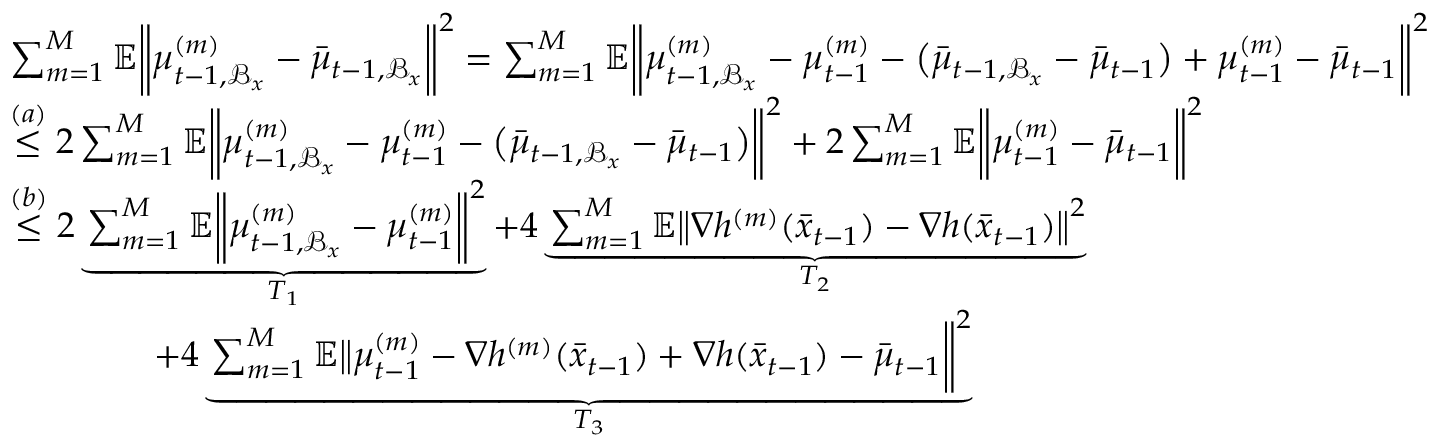Convert formula to latex. <formula><loc_0><loc_0><loc_500><loc_500>\begin{array} { r l } & { \sum _ { m = 1 } ^ { M } \mathbb { E } \left \| \mu _ { t - 1 , \mathcal { B } _ { x } } ^ { ( m ) } - \bar { \mu } _ { t - 1 , \mathcal { B } _ { x } } \right \| ^ { 2 } = \sum _ { m = 1 } ^ { M } \mathbb { E } \left \| \mu _ { t - 1 , \mathcal { B } _ { x } } ^ { ( m ) } - \mu _ { t - 1 } ^ { ( m ) } - \left ( \bar { \mu } _ { t - 1 , \mathcal { B } _ { x } } - \bar { \mu } _ { t - 1 } \right ) + \mu _ { t - 1 } ^ { ( m ) } - \bar { \mu } _ { t - 1 } \right \| ^ { 2 } } \\ & { \overset { ( a ) } { \leq } 2 \sum _ { m = 1 } ^ { M } \mathbb { E } \left \| \mu _ { t - 1 , \mathcal { B } _ { x } } ^ { ( m ) } - \mu _ { t - 1 } ^ { ( m ) } - \left ( \bar { \mu } _ { t - 1 , \mathcal { B } _ { x } } - \bar { \mu } _ { t - 1 } \right ) \right \| ^ { 2 } + 2 \sum _ { m = 1 } ^ { M } \mathbb { E } \left \| \mu _ { t - 1 } ^ { ( m ) } - \bar { \mu } _ { t - 1 } \right \| ^ { 2 } } \\ & { \overset { ( b ) } { \leq } 2 \underbrace { \sum _ { m = 1 } ^ { M } \mathbb { E } \left \| \mu _ { t - 1 , \mathcal { B } _ { x } } ^ { ( m ) } - \mu _ { t - 1 } ^ { ( m ) } \right \| ^ { 2 } } _ { T _ { 1 } } + 4 \underbrace { \sum _ { m = 1 } ^ { M } \mathbb { E } \left \| \nabla h ^ { ( m ) } ( \bar { x } _ { t - 1 } ) - \nabla h ( \bar { x } _ { t - 1 } ) \right \| ^ { 2 } } _ { T _ { 2 } } } \\ & { \quad + 4 \underbrace { \sum _ { m = 1 } ^ { M } \mathbb { E } \left \| \mu _ { t - 1 } ^ { ( m ) } - \nabla h ^ { ( m ) } ( \bar { x } _ { t - 1 } ) + \nabla h ( \bar { x } _ { t - 1 } ) - \bar { \mu } _ { t - 1 } \right \| ^ { 2 } } _ { T _ { 3 } } } \end{array}</formula> 